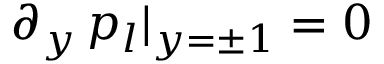Convert formula to latex. <formula><loc_0><loc_0><loc_500><loc_500>\partial _ { y } \, p _ { l } | _ { y = \pm 1 } = 0</formula> 